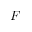Convert formula to latex. <formula><loc_0><loc_0><loc_500><loc_500>F</formula> 